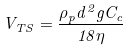Convert formula to latex. <formula><loc_0><loc_0><loc_500><loc_500>V _ { T S } = \frac { \rho _ { p } d ^ { 2 } g C _ { c } } { 1 8 \eta }</formula> 